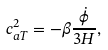Convert formula to latex. <formula><loc_0><loc_0><loc_500><loc_500>c _ { a T } ^ { 2 } = - \beta \frac { \dot { \phi } } { 3 H } ,</formula> 